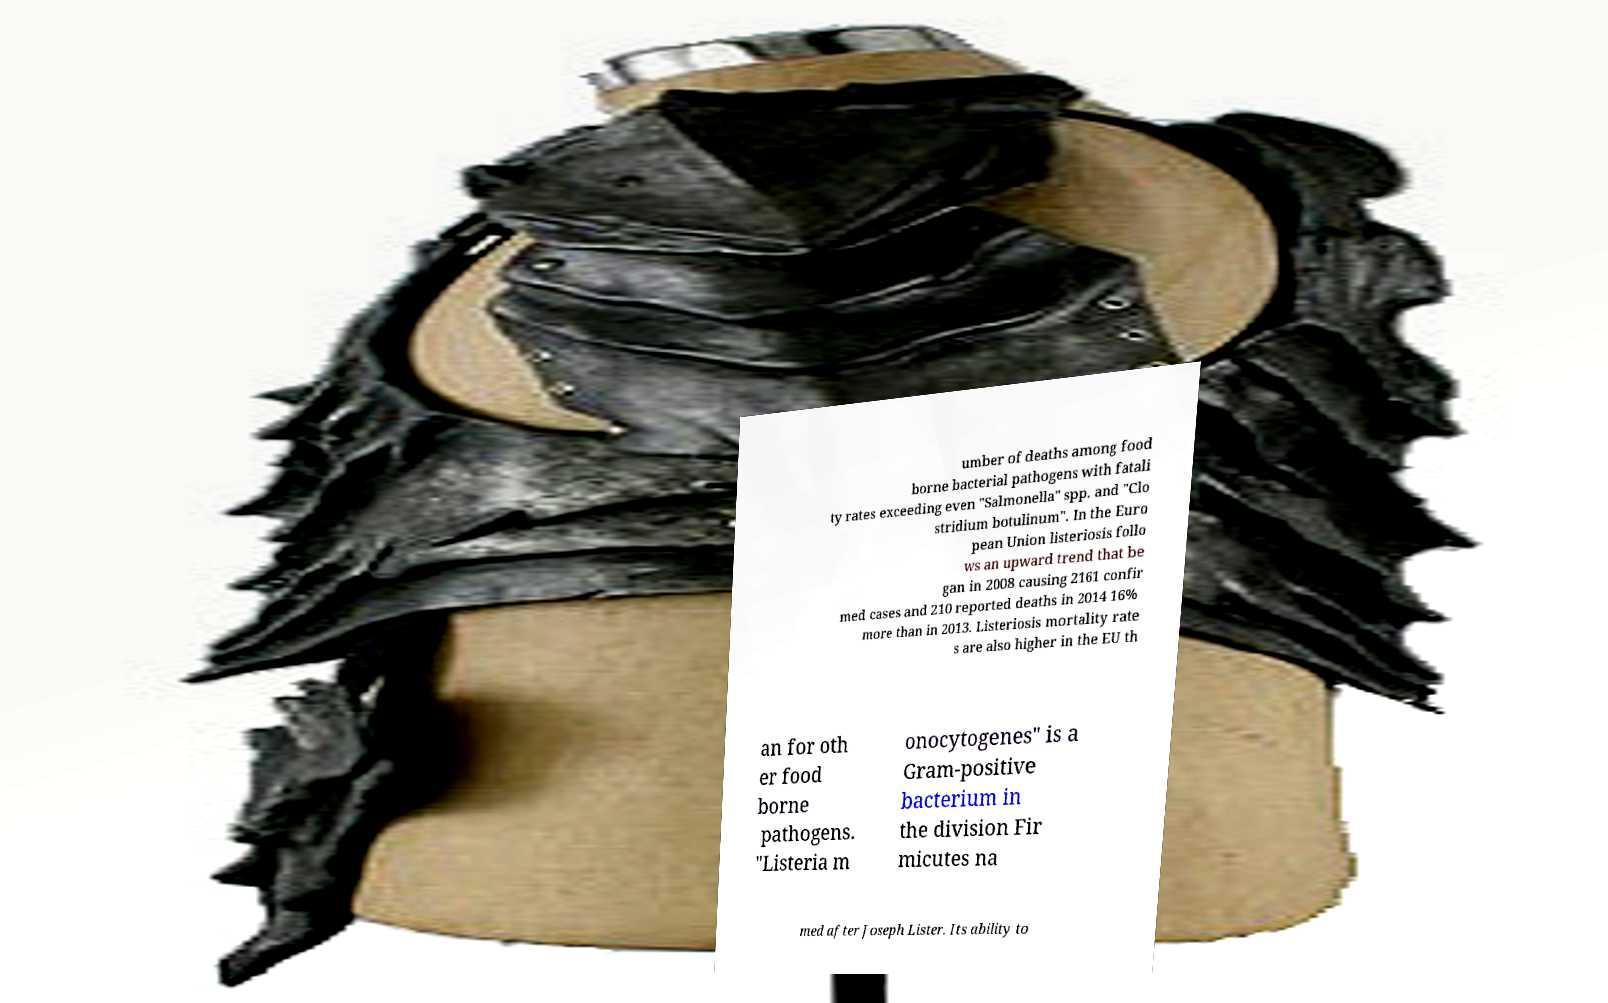Please read and relay the text visible in this image. What does it say? umber of deaths among food borne bacterial pathogens with fatali ty rates exceeding even "Salmonella" spp. and "Clo stridium botulinum". In the Euro pean Union listeriosis follo ws an upward trend that be gan in 2008 causing 2161 confir med cases and 210 reported deaths in 2014 16% more than in 2013. Listeriosis mortality rate s are also higher in the EU th an for oth er food borne pathogens. "Listeria m onocytogenes" is a Gram-positive bacterium in the division Fir micutes na med after Joseph Lister. Its ability to 